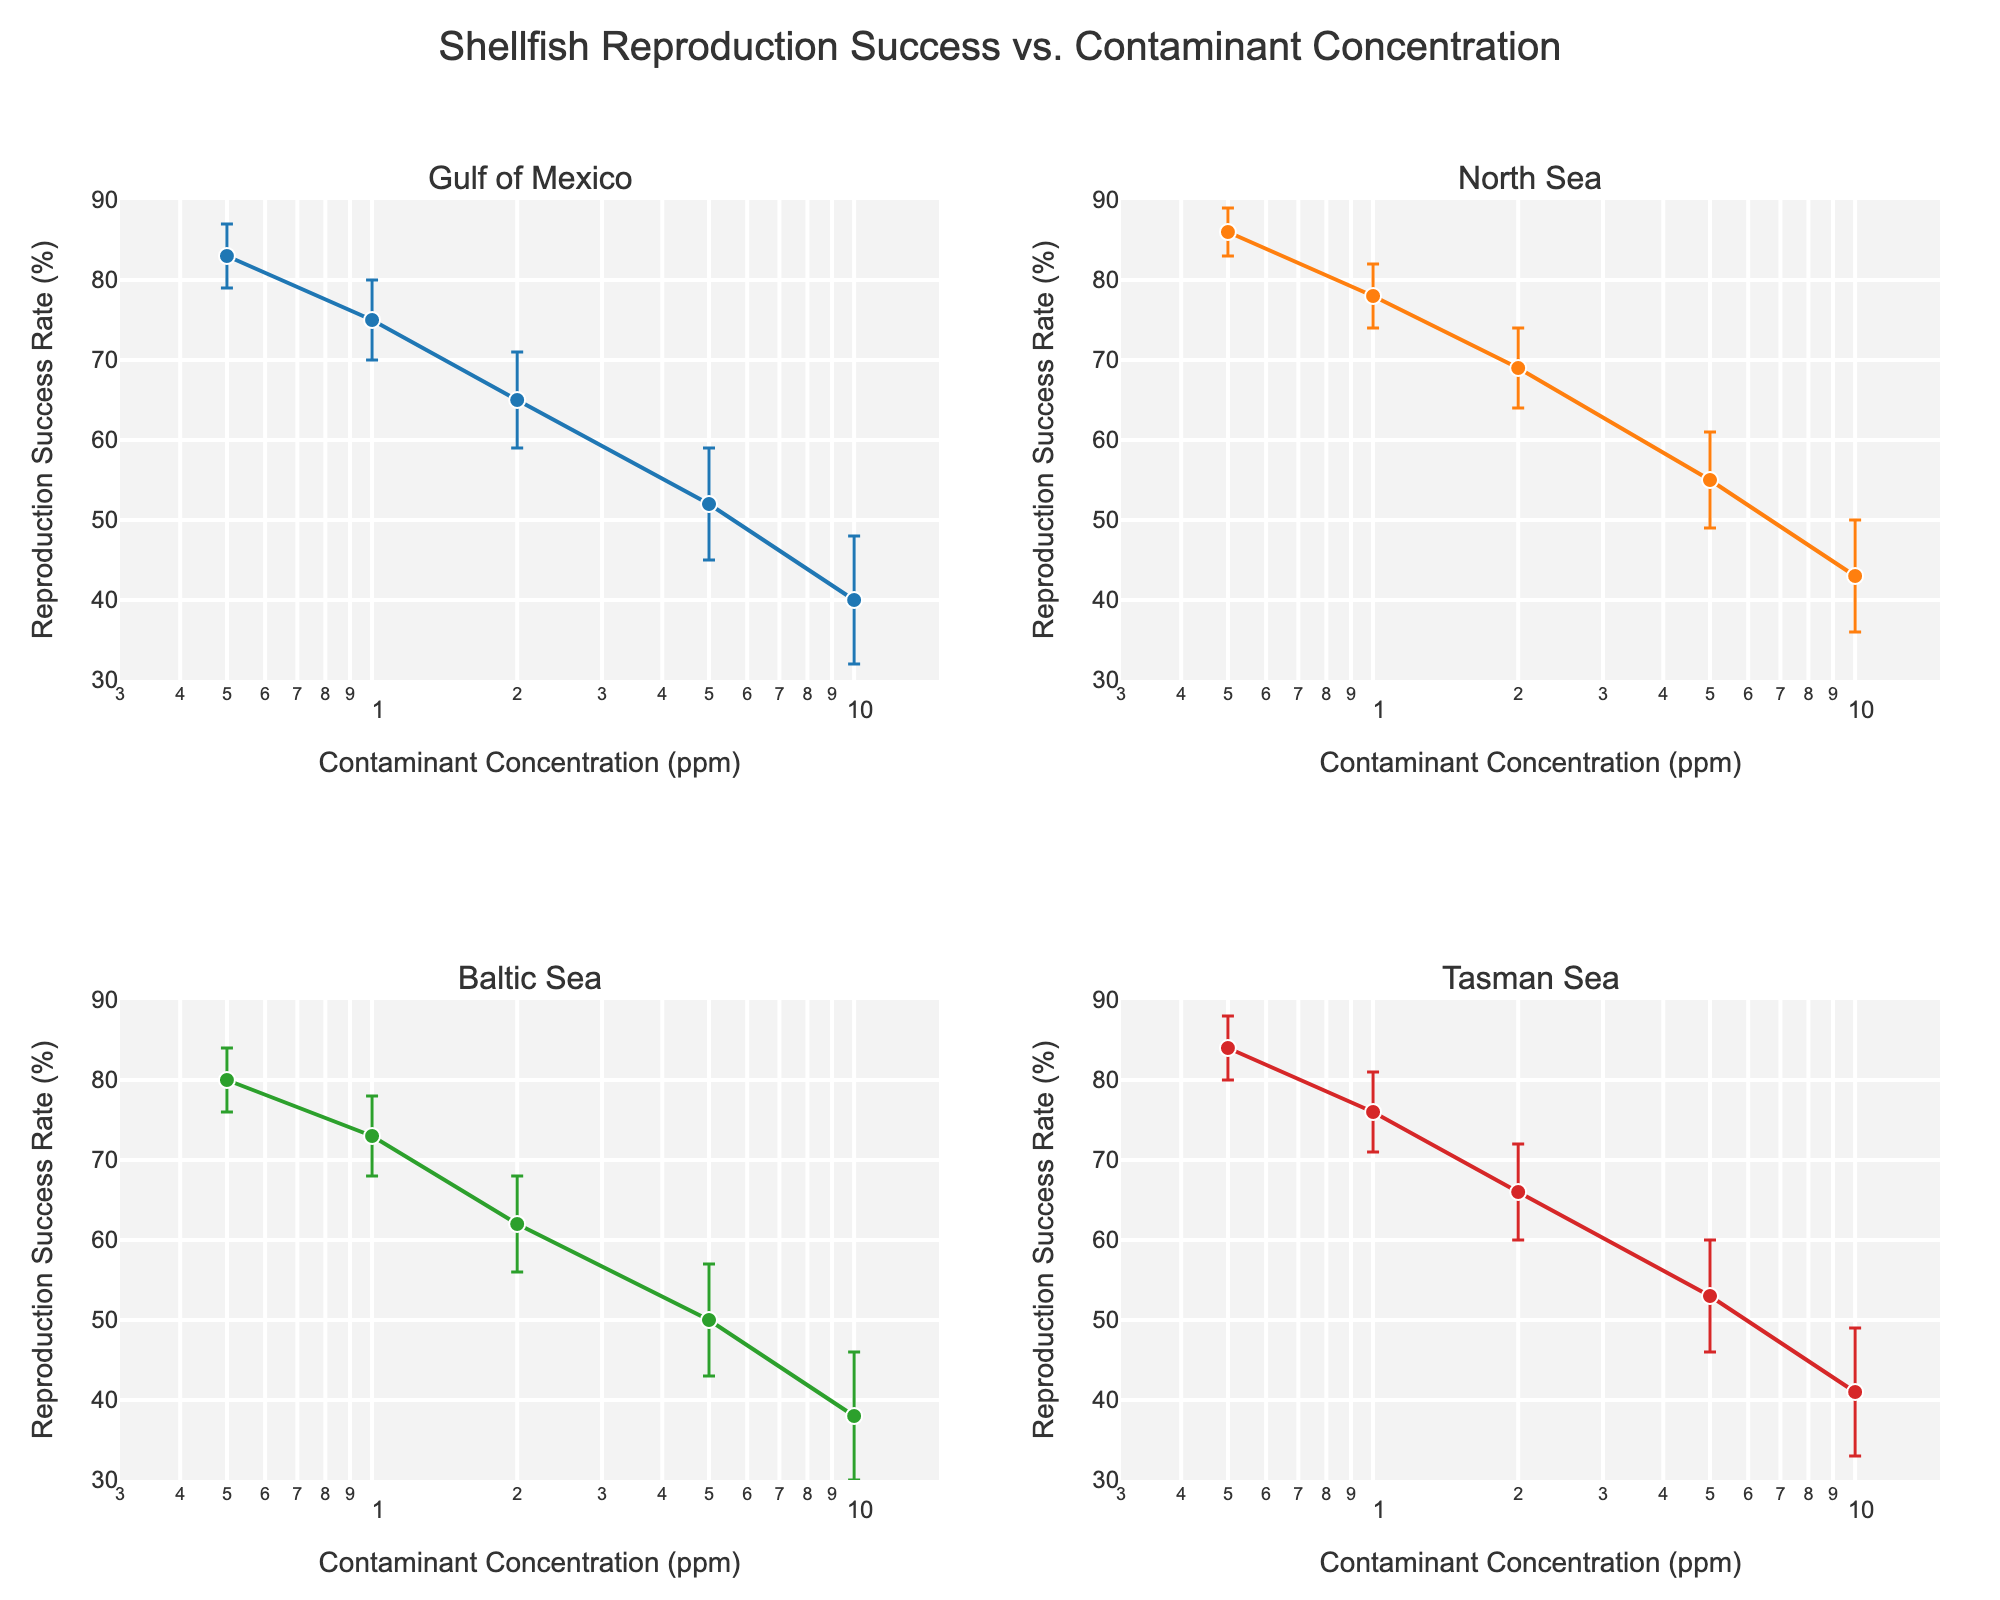What's the title of this plot? The title of the plot is at the top of the figure and is typically the largest and boldest text. It gives an overall description of what the plot represents: "Shellfish Reproduction Success vs. Contaminant Concentration".
Answer: Shellfish Reproduction Success vs. Contaminant Concentration Which reproductive area shows the highest reproduction success rate at 0.5 ppm? By looking at the subplot titles and the data points at 0.5 ppm for each area, we can compare the reproduction success rates. The North Sea shows the highest value at 86%.
Answer: North Sea At which contaminant concentration do the Gulf of Mexico and Tasman Sea have the same reproduction success rate? We need to find a common value between the Gulf of Mexico and Tasman Sea subplots. Both areas show a reproduction success rate of 41% at 10 ppm.
Answer: 10 ppm What is the trend in the reproduction success rate as contaminant concentration increases in the Gulf of Mexico? Observing the Gulf of Mexico subplot, the reproduction success rate consistently decreases as the contaminant concentration increases from 0.5 ppm to 10 ppm.
Answer: Decreases What's the difference in reproduction success rates between 0.5 ppm and 10 ppm in the Baltic Sea? We calculate the difference by subtracting the reproduction success rate at 10 ppm (38%) from the rate at 0.5 ppm (80%). The difference is 80% - 38% = 42%.
Answer: 42% How do the error bars at 1.0 ppm in the Gulf of Mexico compare to those in the Tasman Sea? The error bars represent the variability in the data. By looking at the length of the bars at 1.0 ppm, we can see that the Gulf of Mexico has error bars of ±5%, while the Tasman Sea has error bars of ±5%. Thus, they are the same in length.
Answer: Same Which area shows the least variability in reproduction success rates across all contaminant concentrations? We can determine this by comparing the lengths of the error bars across subplots. The North Sea generally has shorter error bars, indicating less variability in its measurements.
Answer: North Sea Is there any area where the reproduction success rate is higher than 50% at a concentration of 5.0 ppm? By examining the data points at 5.0 ppm, only the North Sea has a reproduction success rate above 50%, which is 55%.
Answer: Yes What's the average reproduction success rate at 2.0 ppm for all areas? We find the rates for all areas at 2.0 ppm (Gulf of Mexico 65%, North Sea 69%, Baltic Sea 62%, Tasman Sea 66%) and calculate the average: (65 + 69 + 62 + 66) / 4 = 65.5%.
Answer: 65.5% 